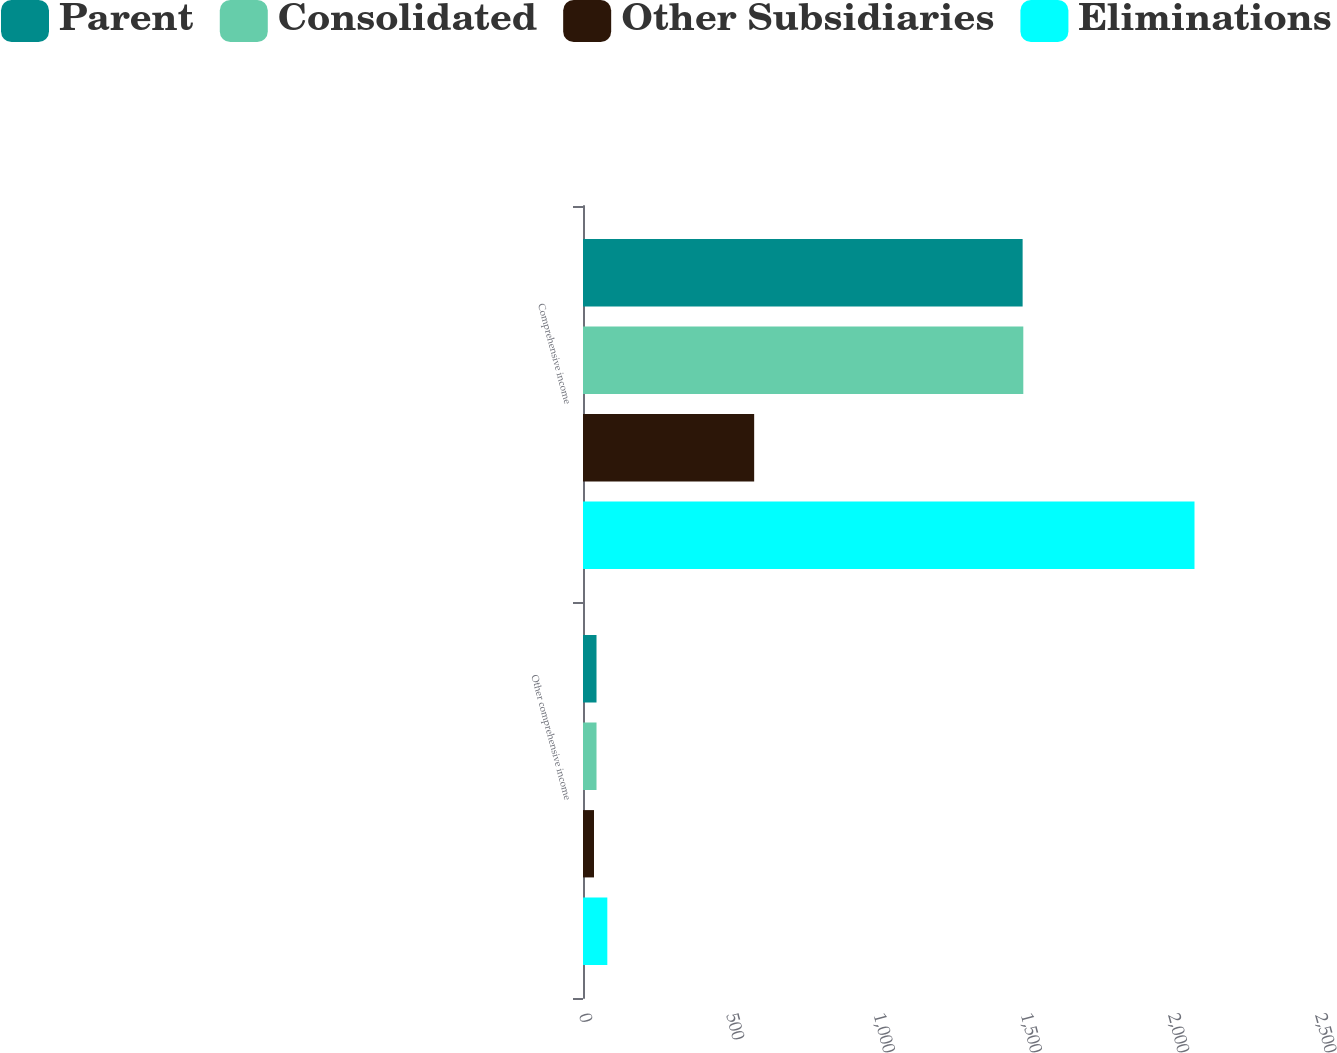Convert chart. <chart><loc_0><loc_0><loc_500><loc_500><stacked_bar_chart><ecel><fcel>Other comprehensive income<fcel>Comprehensive income<nl><fcel>Parent<fcel>45.9<fcel>1493.3<nl><fcel>Consolidated<fcel>45.9<fcel>1495.6<nl><fcel>Other Subsidiaries<fcel>37.4<fcel>581.4<nl><fcel>Eliminations<fcel>82.6<fcel>2077.1<nl></chart> 